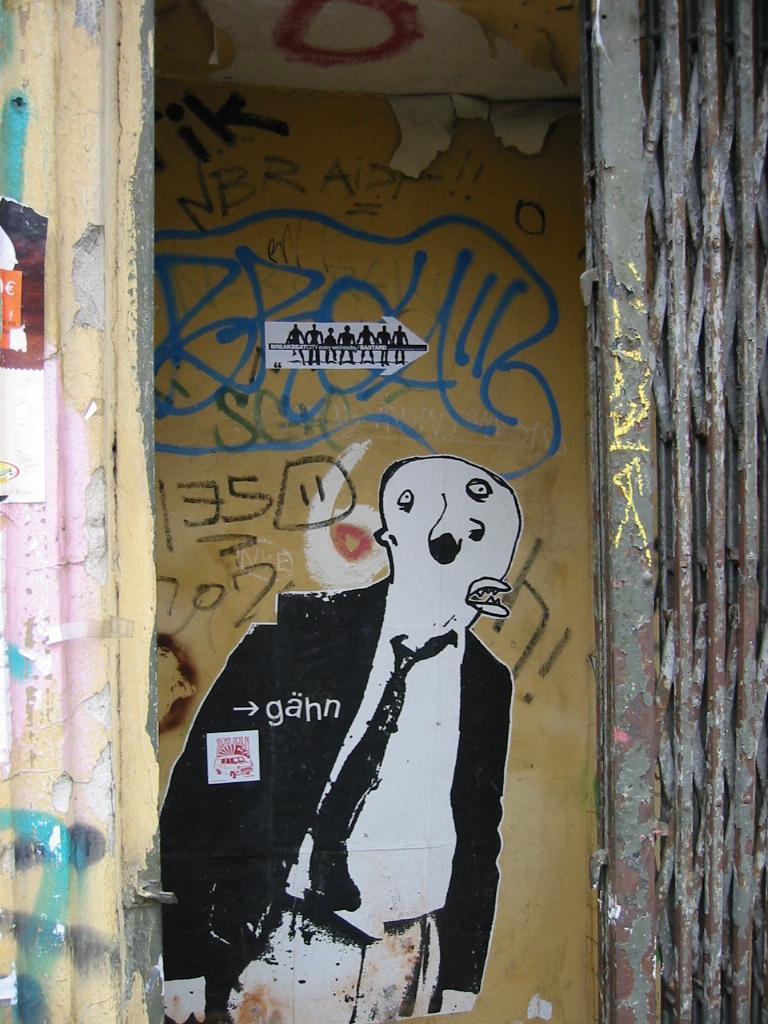In one or two sentences, can you explain what this image depicts? In this image in front there is a gate. In the background of the image there is a painting on the wall. 